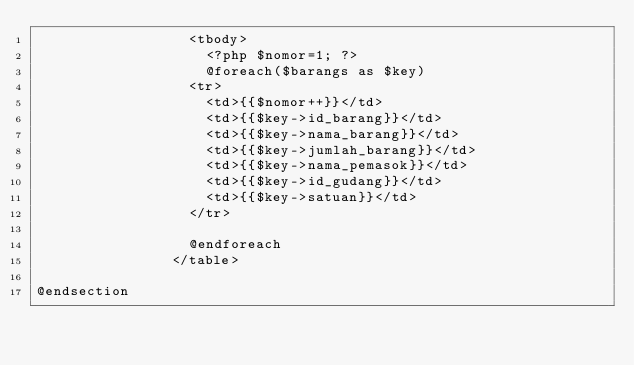Convert code to text. <code><loc_0><loc_0><loc_500><loc_500><_PHP_>                  <tbody>
                    <?php $nomor=1; ?>
                    @foreach($barangs as $key)
                  <tr>
                    <td>{{$nomor++}}</td>
                    <td>{{$key->id_barang}}</td>
                    <td>{{$key->nama_barang}}</td>
                    <td>{{$key->jumlah_barang}}</td>
                    <td>{{$key->nama_pemasok}}</td>
                    <td>{{$key->id_gudang}}</td>
                    <td>{{$key->satuan}}</td>
                  </tr>

                  @endforeach
                </table>
             
@endsection</code> 